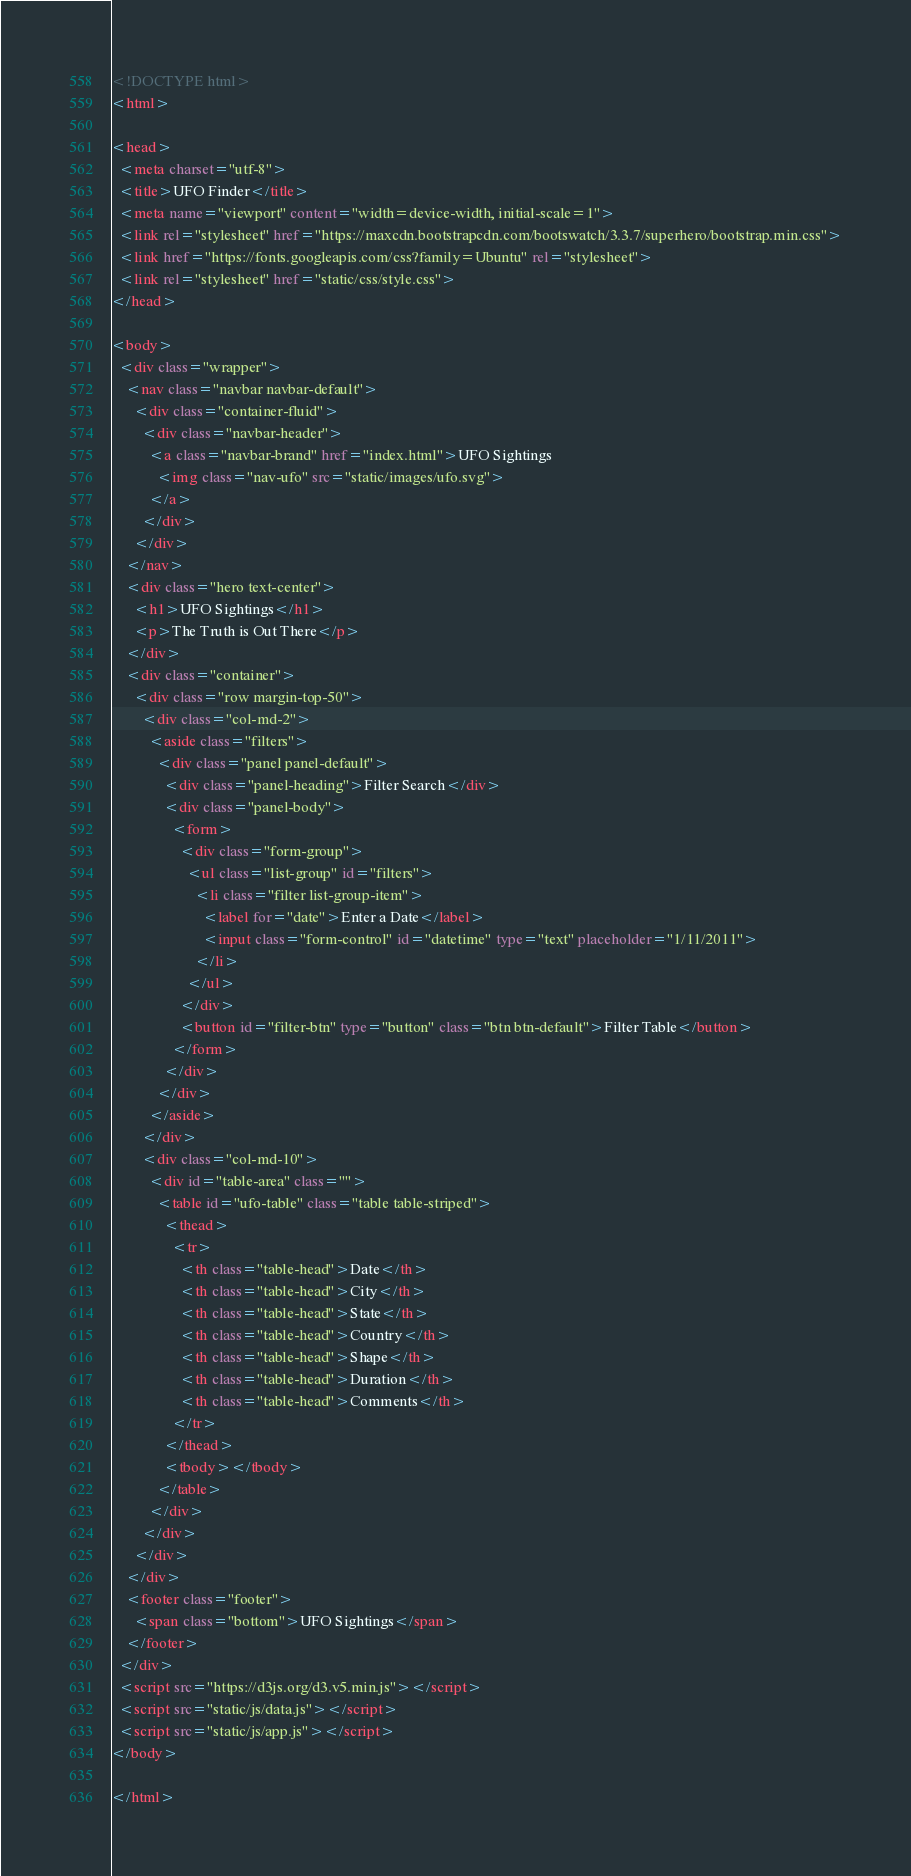<code> <loc_0><loc_0><loc_500><loc_500><_HTML_><!DOCTYPE html>
<html>

<head>
  <meta charset="utf-8">
  <title>UFO Finder</title>
  <meta name="viewport" content="width=device-width, initial-scale=1">
  <link rel="stylesheet" href="https://maxcdn.bootstrapcdn.com/bootswatch/3.3.7/superhero/bootstrap.min.css">
  <link href="https://fonts.googleapis.com/css?family=Ubuntu" rel="stylesheet">
  <link rel="stylesheet" href="static/css/style.css">
</head>

<body>
  <div class="wrapper">
    <nav class="navbar navbar-default">
      <div class="container-fluid">
        <div class="navbar-header">
          <a class="navbar-brand" href="index.html">UFO Sightings
            <img class="nav-ufo" src="static/images/ufo.svg">
          </a>
        </div>
      </div>
    </nav>
    <div class="hero text-center">
      <h1>UFO Sightings</h1>
      <p>The Truth is Out There</p>
    </div>
    <div class="container">
      <div class="row margin-top-50">
        <div class="col-md-2">
          <aside class="filters">
            <div class="panel panel-default">
              <div class="panel-heading">Filter Search</div>
              <div class="panel-body">
                <form>
                  <div class="form-group">
                    <ul class="list-group" id="filters">
                      <li class="filter list-group-item">
                        <label for="date">Enter a Date</label>
                        <input class="form-control" id="datetime" type="text" placeholder="1/11/2011">
                      </li>
                    </ul>
                  </div>
                  <button id="filter-btn" type="button" class="btn btn-default">Filter Table</button>
                </form>
              </div>
            </div>
          </aside>
        </div>
        <div class="col-md-10">
          <div id="table-area" class="">
            <table id="ufo-table" class="table table-striped">
              <thead>
                <tr>
                  <th class="table-head">Date</th>
                  <th class="table-head">City</th>
                  <th class="table-head">State</th>
                  <th class="table-head">Country</th>
                  <th class="table-head">Shape</th>
                  <th class="table-head">Duration</th>
                  <th class="table-head">Comments</th>
                </tr>
              </thead>
              <tbody></tbody>
            </table>
          </div>
        </div>
      </div>
    </div>
    <footer class="footer">
      <span class="bottom">UFO Sightings</span>
    </footer>
  </div>
  <script src="https://d3js.org/d3.v5.min.js"></script>
  <script src="static/js/data.js"></script>
  <script src="static/js/app.js"></script>
</body>

</html></code> 